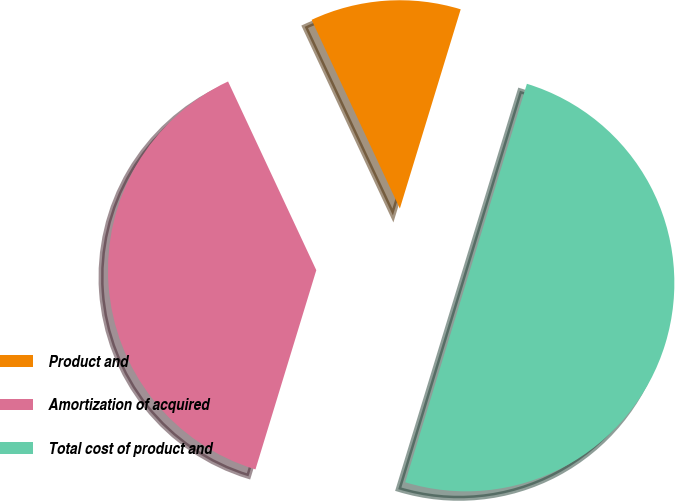Convert chart. <chart><loc_0><loc_0><loc_500><loc_500><pie_chart><fcel>Product and<fcel>Amortization of acquired<fcel>Total cost of product and<nl><fcel>11.68%<fcel>38.32%<fcel>50.0%<nl></chart> 